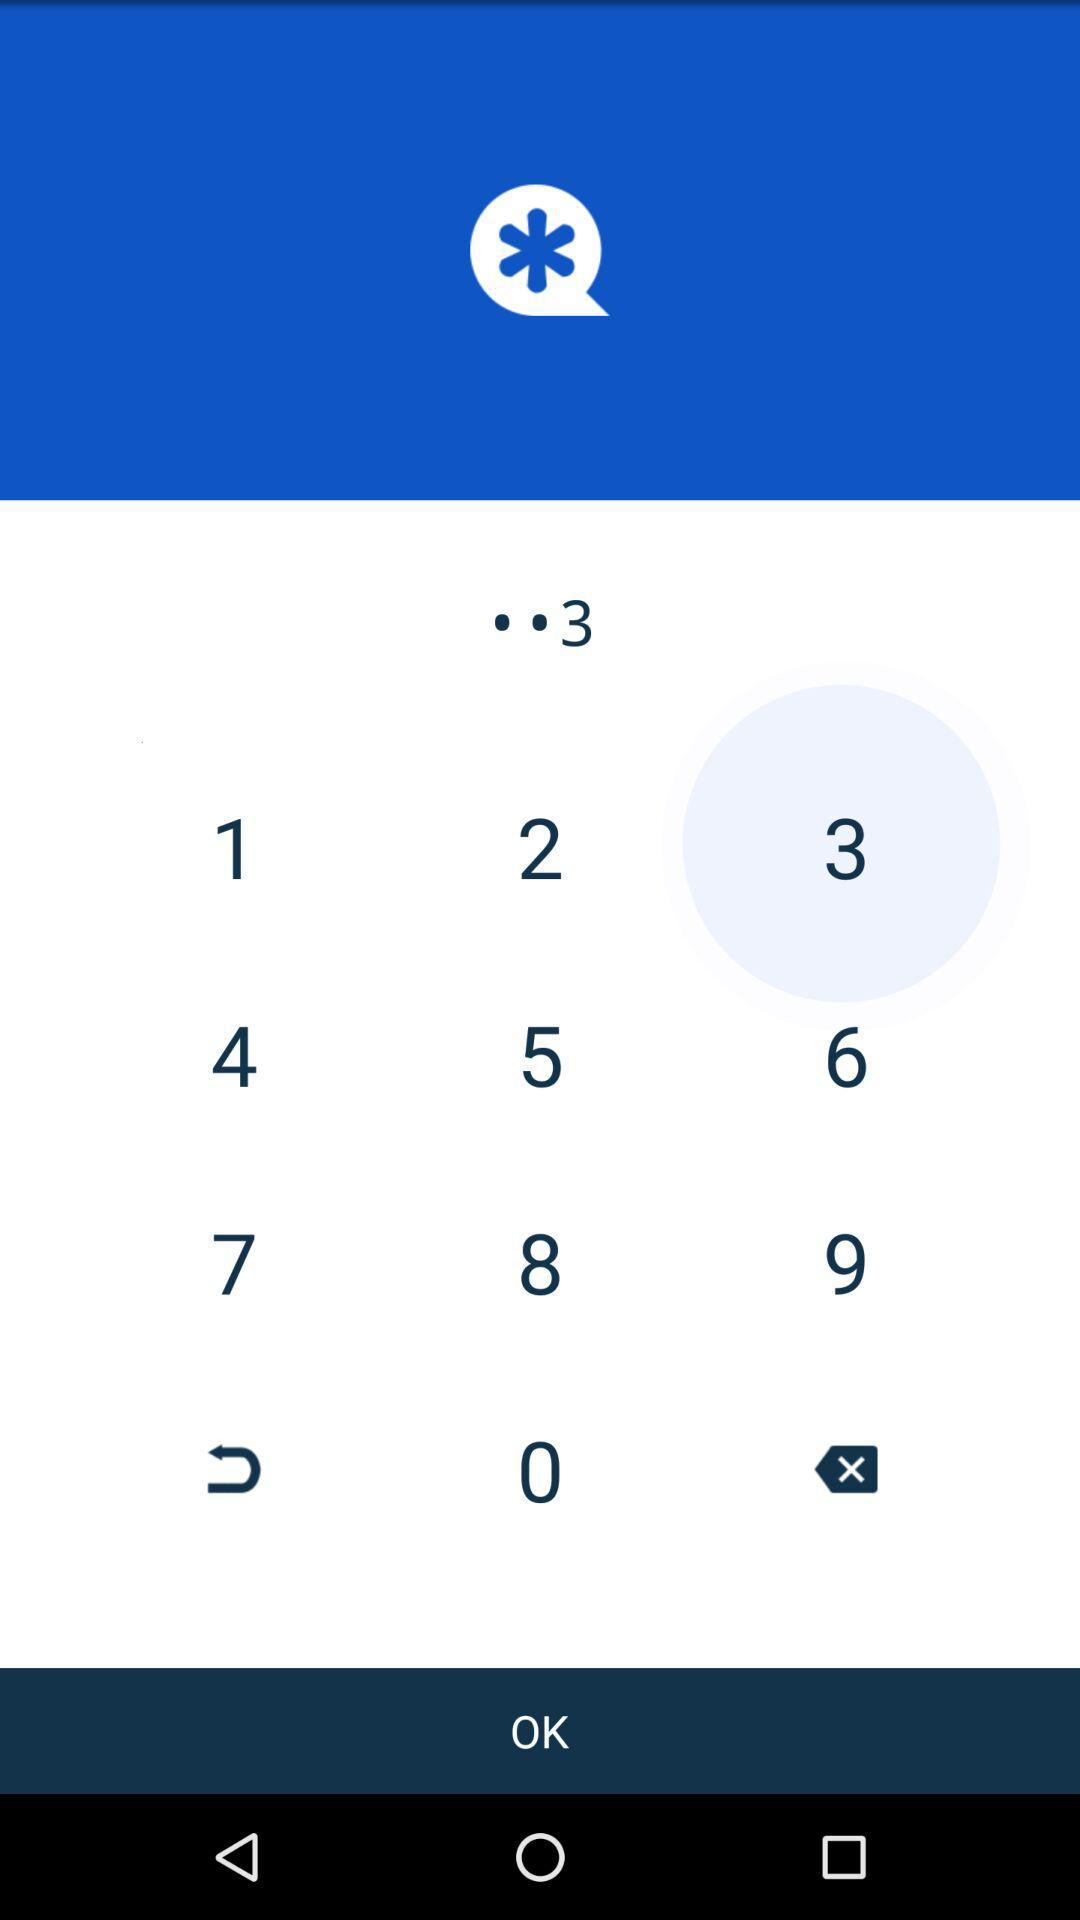What is the complete phone number?
When the provided information is insufficient, respond with <no answer>. <no answer> 